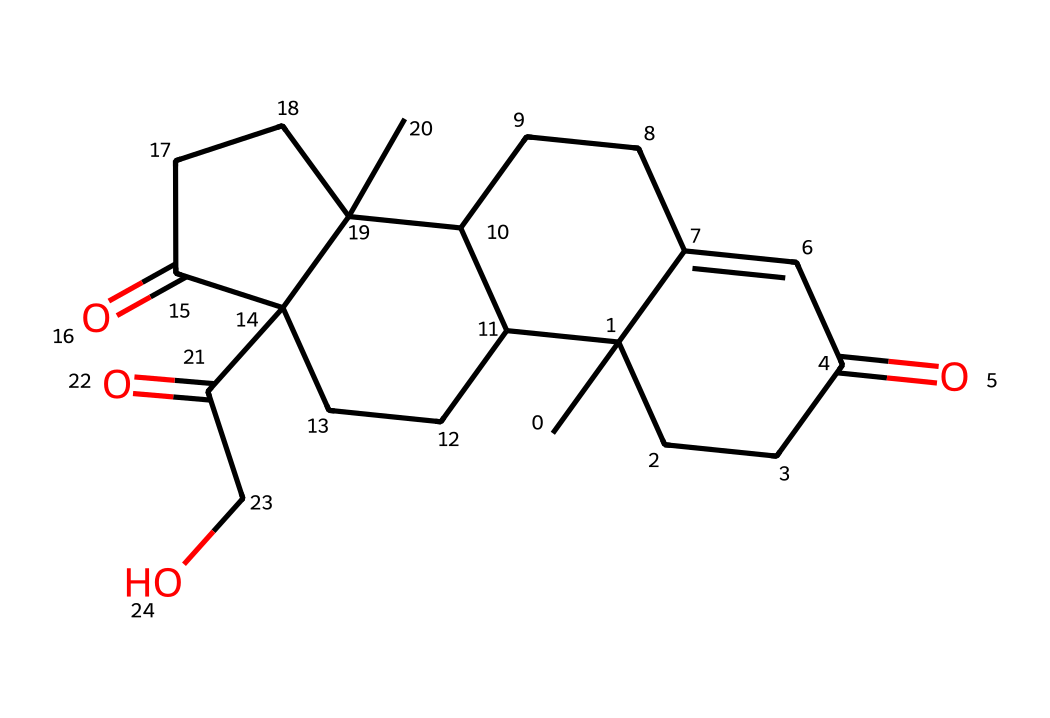What is the molecular formula of cortisol? To determine the molecular formula from the SMILES representation, we can count the number of each type of atom present. In this case, we can count 21 carbons, 30 hydrogens, and 5 oxygens. Thus, the molecular formula becomes C21H30O5.
Answer: C21H30O5 How many rings are present in the cortisol structure? By analyzing the chemical structure from the SMILES, we identify that there are four distinct interconnected rings present in the structure of cortisol.
Answer: 4 What functional groups are present in cortisol? By examining the structure closely, we identify the presence of two carbonyl groups (C=O) and one hydroxyl group (-OH), which are characteristic functional groups in cortisol.
Answer: carbonyl, hydroxyl What is the total number of oxygen atoms in the cortisol molecule? Counting the number of oxygen atoms present in the structure from the SMILES, we find that there are a total of 5 oxygen atoms in the cortisol molecule.
Answer: 5 Which type of chemical is cortisol classified as? Cortisol is classified as a steroid hormone due to its structure, which has a steroid backbone with 4 fused rings and functional groups that are typical of steroid hormones.
Answer: steroid hormone How does the structure of cortisol relate to its function as a stress hormone? The molecular structure of cortisol, which includes hydroxyl and carbonyl groups, allows it to interact with specific receptors in the body, facilitating its role in regulating metabolic processes and the stress response. The way it fits into receptors is critical for its function as a stress hormone.
Answer: regulates stress response 